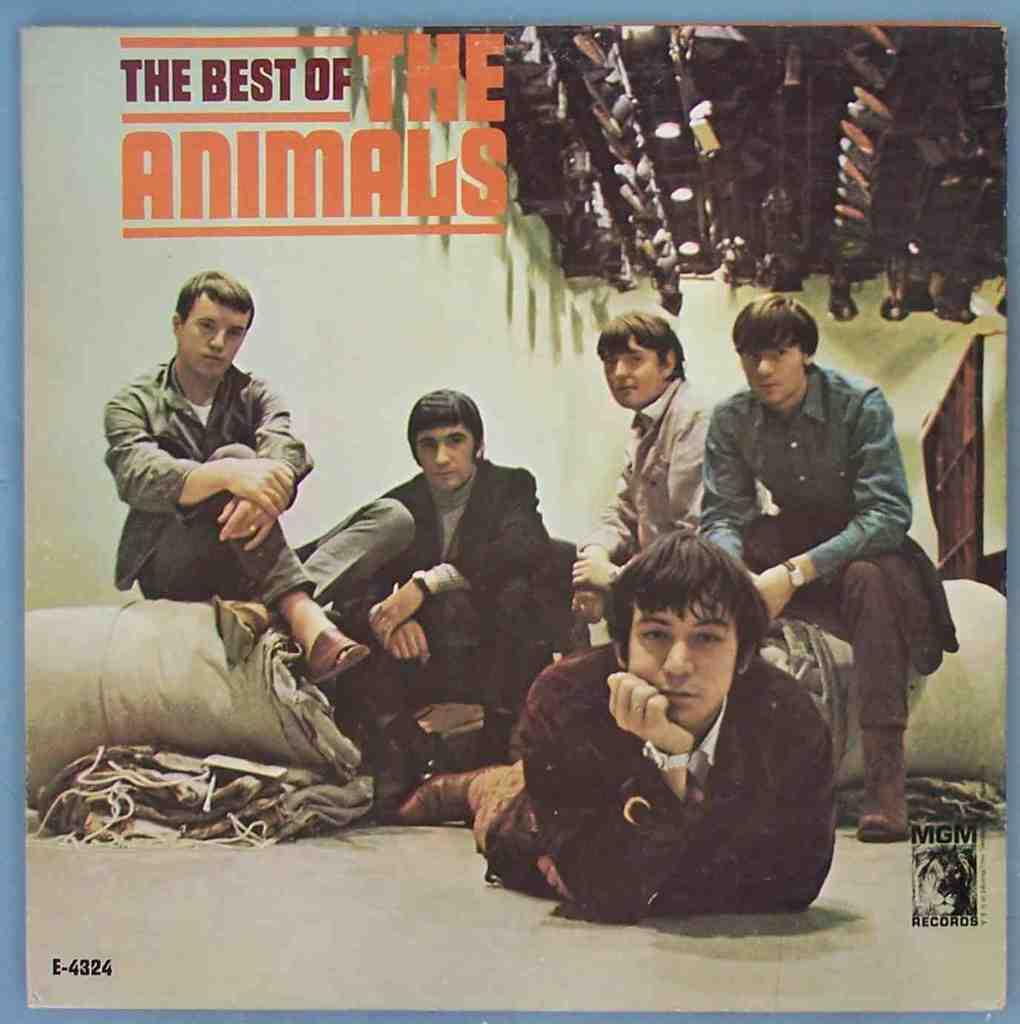What is present in the image that contains both images and text? There is a poster in the image that contains images and text. What type of milk is being advertised on the poster in the image? There is no milk being advertised on the poster in the image, as the facts provided do not mention any milk or advertisement. 